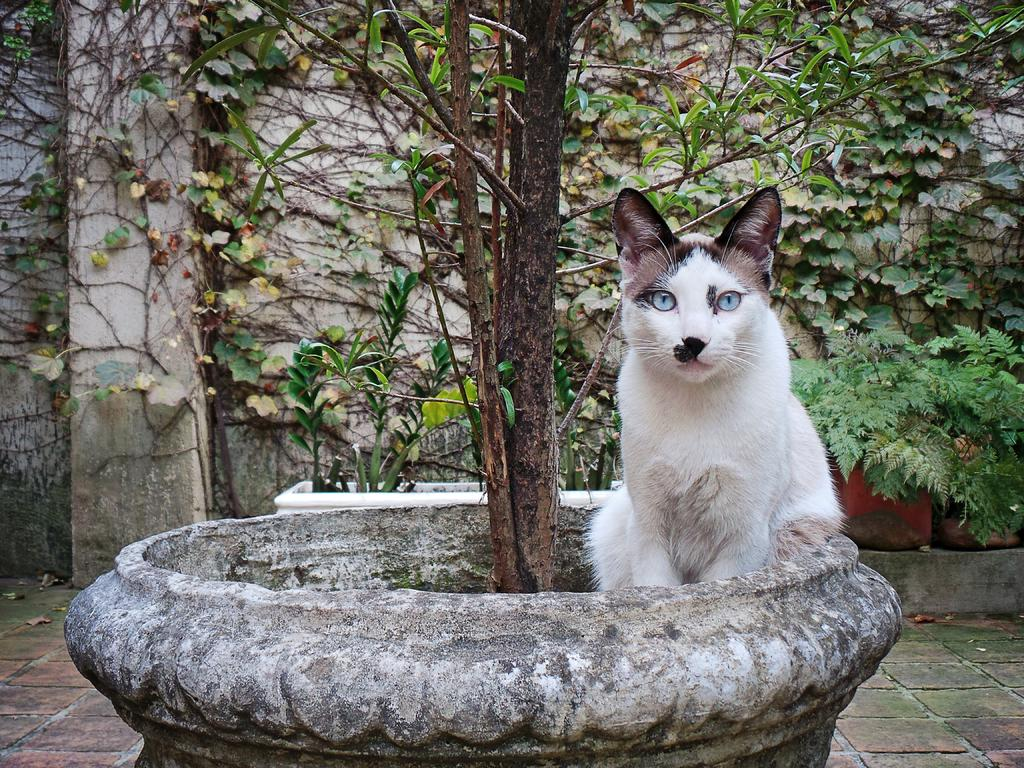What type of animal can be seen in the image? There is a cat in the image. What objects are present in the image that might be used for gardening? There are pots in the image that could be used for gardening. What type of vegetation is visible in the image? There are plants in the image. What is on the ground in the image? Leaves are present on the ground in the image. What can be seen in the background of the image? There is a wall visible in the background of the image. What type of songs is the cat singing in the image? There is no indication in the image that the cat is singing any songs. 